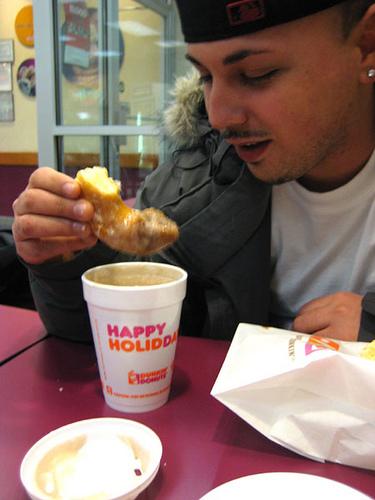What month was this picture taken in?
Concise answer only. December. What store sold that coffee?
Be succinct. Dunkin donuts. What is the person holding in his hand?
Be succinct. Donut. Is the man dunking his donut in coffee?
Be succinct. Yes. 